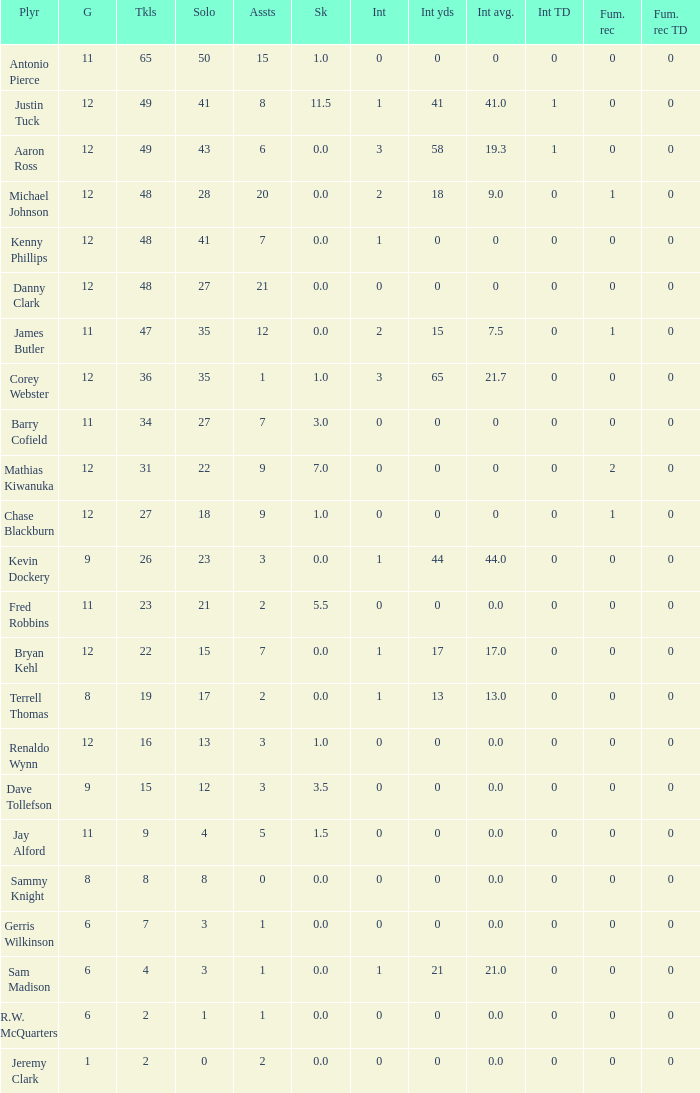Name the most tackles for 3.5 sacks 15.0. 